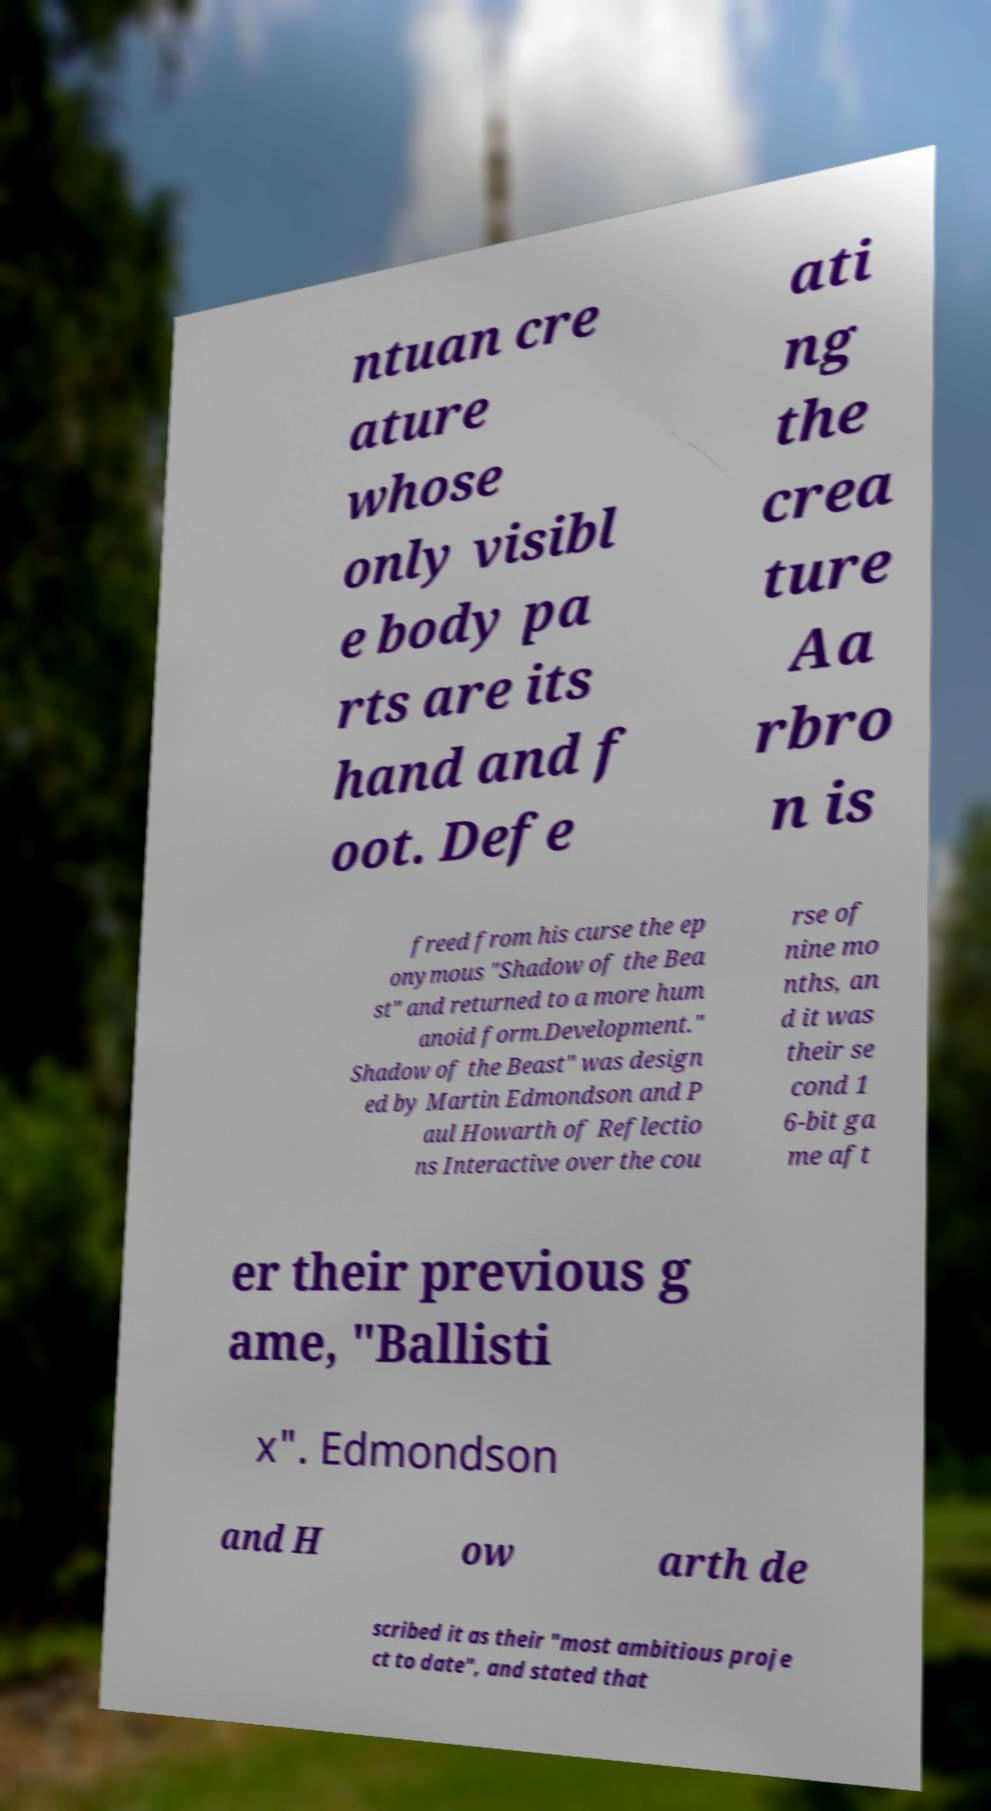Could you extract and type out the text from this image? ntuan cre ature whose only visibl e body pa rts are its hand and f oot. Defe ati ng the crea ture Aa rbro n is freed from his curse the ep onymous "Shadow of the Bea st" and returned to a more hum anoid form.Development." Shadow of the Beast" was design ed by Martin Edmondson and P aul Howarth of Reflectio ns Interactive over the cou rse of nine mo nths, an d it was their se cond 1 6-bit ga me aft er their previous g ame, "Ballisti x". Edmondson and H ow arth de scribed it as their "most ambitious proje ct to date", and stated that 